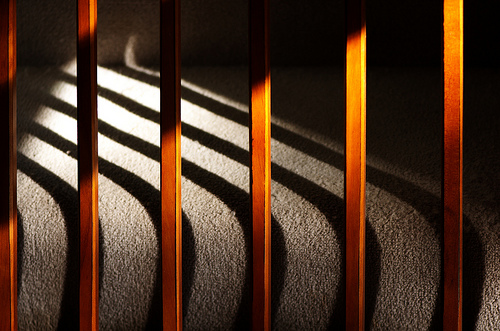<image>
Can you confirm if the shadow is behind the spindle? Yes. From this viewpoint, the shadow is positioned behind the spindle, with the spindle partially or fully occluding the shadow. 